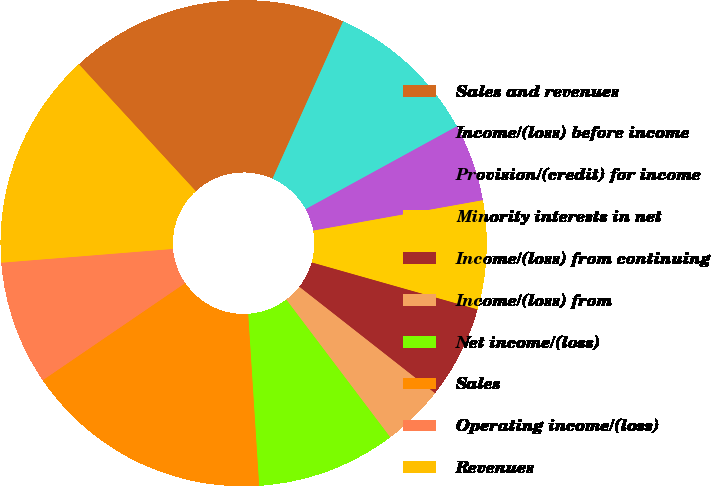Convert chart to OTSL. <chart><loc_0><loc_0><loc_500><loc_500><pie_chart><fcel>Sales and revenues<fcel>Income/(loss) before income<fcel>Provision/(credit) for income<fcel>Minority interests in net<fcel>Income/(loss) from continuing<fcel>Income/(loss) from<fcel>Net income/(loss)<fcel>Sales<fcel>Operating income/(loss)<fcel>Revenues<nl><fcel>18.56%<fcel>10.31%<fcel>5.15%<fcel>7.22%<fcel>6.19%<fcel>4.12%<fcel>9.28%<fcel>16.49%<fcel>8.25%<fcel>14.43%<nl></chart> 